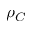<formula> <loc_0><loc_0><loc_500><loc_500>\rho _ { C }</formula> 